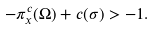Convert formula to latex. <formula><loc_0><loc_0><loc_500><loc_500>- \pi _ { x } ^ { c } ( \Omega ) + c ( \sigma ) > - 1 .</formula> 